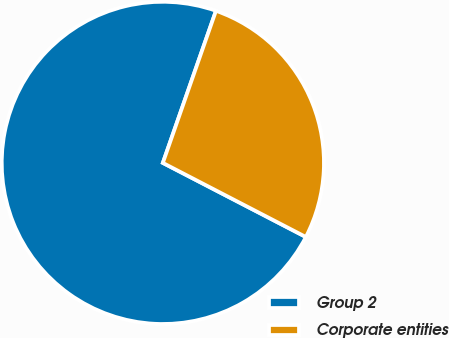Convert chart. <chart><loc_0><loc_0><loc_500><loc_500><pie_chart><fcel>Group 2<fcel>Corporate entities<nl><fcel>72.74%<fcel>27.26%<nl></chart> 